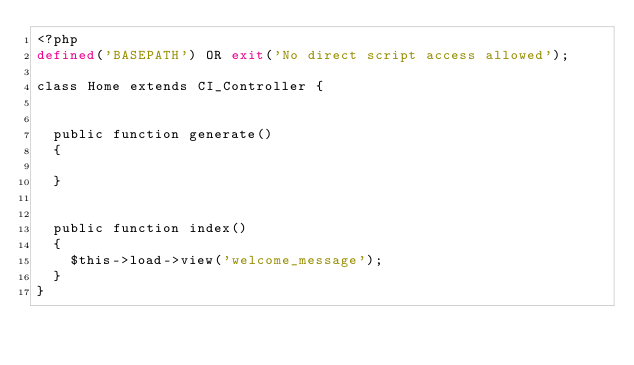Convert code to text. <code><loc_0><loc_0><loc_500><loc_500><_PHP_><?php
defined('BASEPATH') OR exit('No direct script access allowed');

class Home extends CI_Controller {


	public function generate()
	{
		
	}


	public function index()
	{
		$this->load->view('welcome_message');
	}
}
</code> 